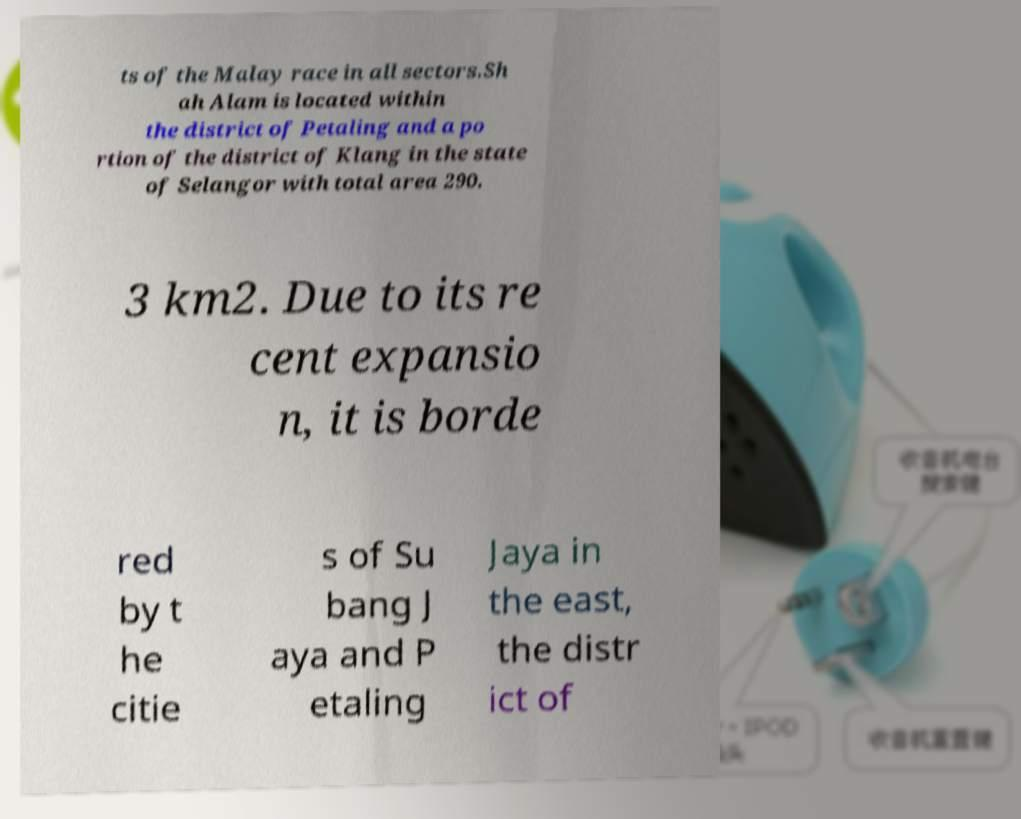Can you read and provide the text displayed in the image?This photo seems to have some interesting text. Can you extract and type it out for me? ts of the Malay race in all sectors.Sh ah Alam is located within the district of Petaling and a po rtion of the district of Klang in the state of Selangor with total area 290. 3 km2. Due to its re cent expansio n, it is borde red by t he citie s of Su bang J aya and P etaling Jaya in the east, the distr ict of 